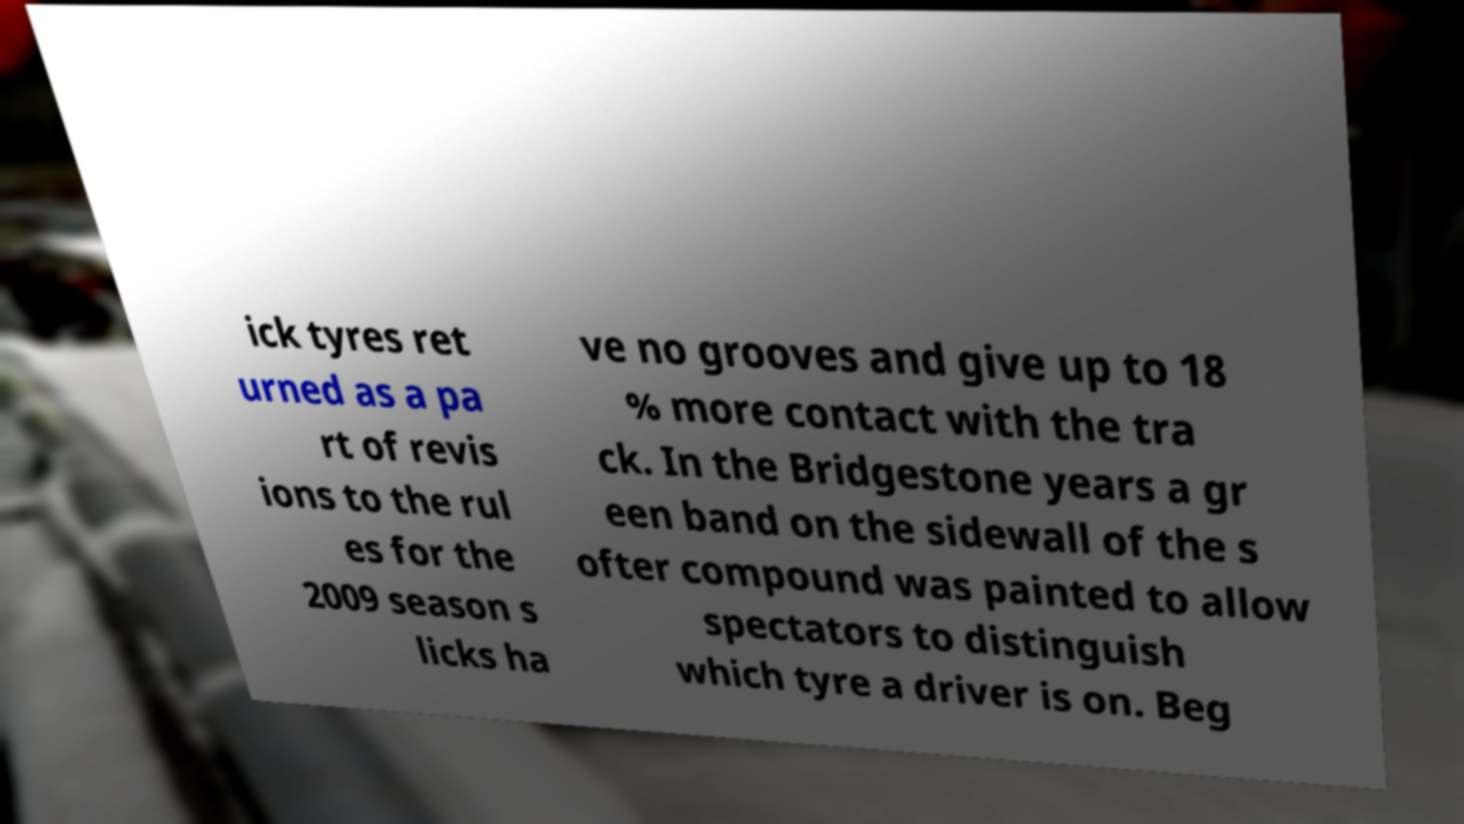There's text embedded in this image that I need extracted. Can you transcribe it verbatim? ick tyres ret urned as a pa rt of revis ions to the rul es for the 2009 season s licks ha ve no grooves and give up to 18 % more contact with the tra ck. In the Bridgestone years a gr een band on the sidewall of the s ofter compound was painted to allow spectators to distinguish which tyre a driver is on. Beg 